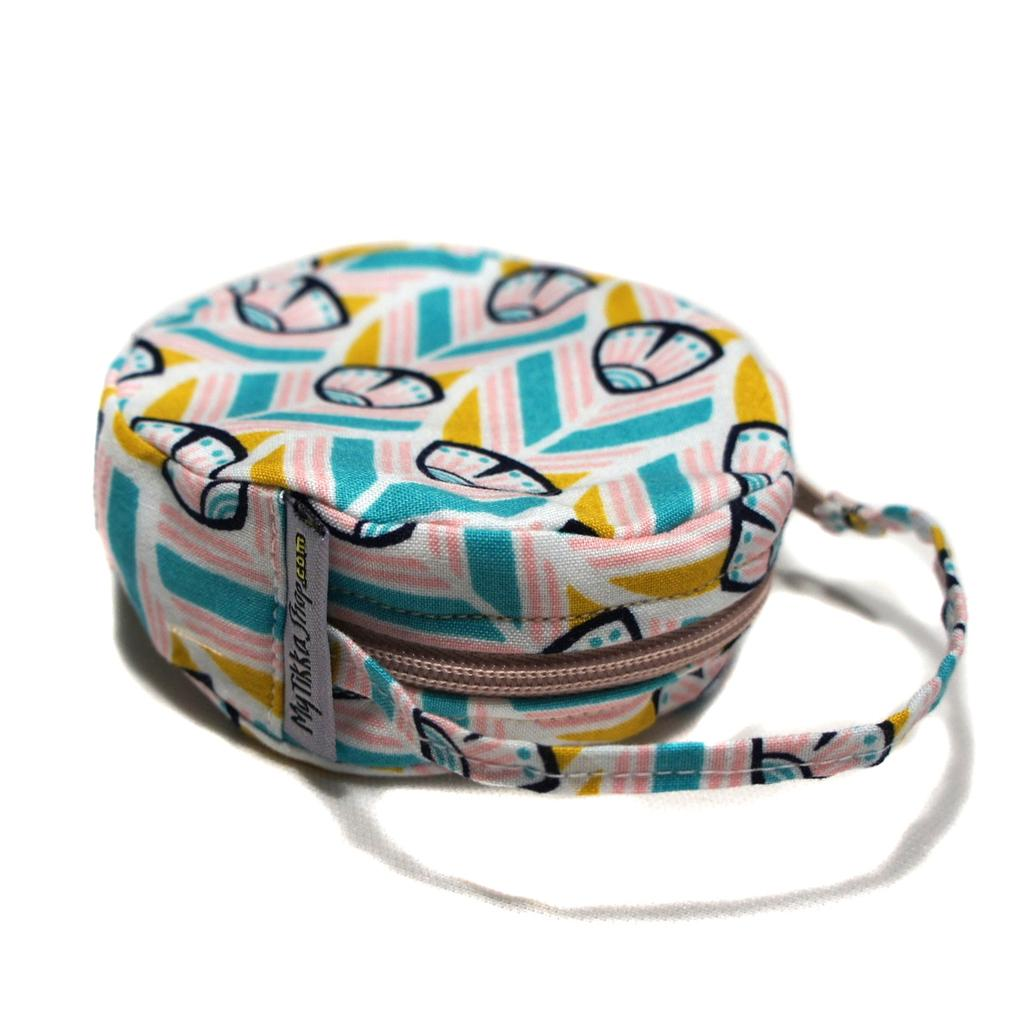What is the most prominent colorful object in the image? There is a colorful bag in the image. What is the background color of the image? The remaining portion of the image is in white color. What is the name of the downtown street in the image? There is no mention of a downtown street in the image. 